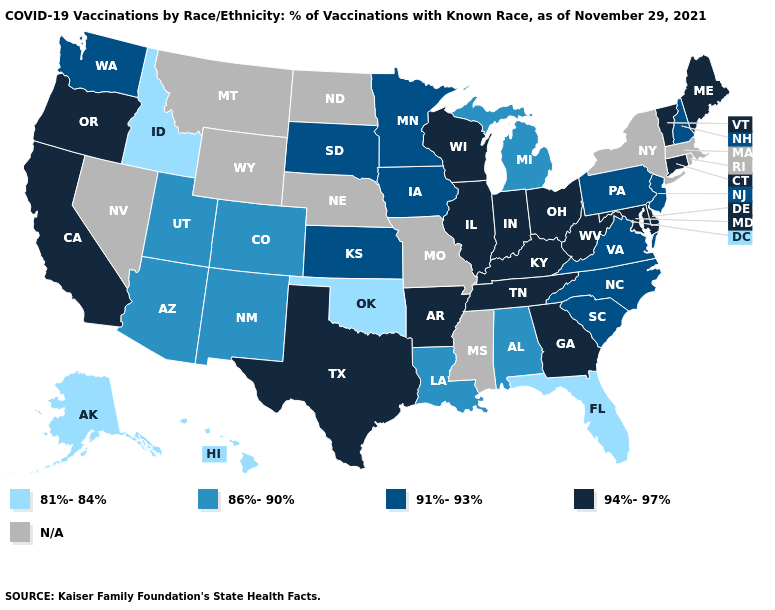Which states hav the highest value in the South?
Answer briefly. Arkansas, Delaware, Georgia, Kentucky, Maryland, Tennessee, Texas, West Virginia. What is the highest value in states that border Wyoming?
Keep it brief. 91%-93%. Does the map have missing data?
Answer briefly. Yes. What is the value of New Mexico?
Concise answer only. 86%-90%. Name the states that have a value in the range 94%-97%?
Short answer required. Arkansas, California, Connecticut, Delaware, Georgia, Illinois, Indiana, Kentucky, Maine, Maryland, Ohio, Oregon, Tennessee, Texas, Vermont, West Virginia, Wisconsin. Name the states that have a value in the range 94%-97%?
Short answer required. Arkansas, California, Connecticut, Delaware, Georgia, Illinois, Indiana, Kentucky, Maine, Maryland, Ohio, Oregon, Tennessee, Texas, Vermont, West Virginia, Wisconsin. Among the states that border Idaho , does Utah have the lowest value?
Write a very short answer. Yes. Which states have the lowest value in the South?
Give a very brief answer. Florida, Oklahoma. Name the states that have a value in the range 91%-93%?
Quick response, please. Iowa, Kansas, Minnesota, New Hampshire, New Jersey, North Carolina, Pennsylvania, South Carolina, South Dakota, Virginia, Washington. How many symbols are there in the legend?
Give a very brief answer. 5. What is the value of New Jersey?
Short answer required. 91%-93%. Name the states that have a value in the range 94%-97%?
Answer briefly. Arkansas, California, Connecticut, Delaware, Georgia, Illinois, Indiana, Kentucky, Maine, Maryland, Ohio, Oregon, Tennessee, Texas, Vermont, West Virginia, Wisconsin. Does Iowa have the highest value in the USA?
Short answer required. No. What is the highest value in states that border Wyoming?
Answer briefly. 91%-93%. Does the first symbol in the legend represent the smallest category?
Quick response, please. Yes. 